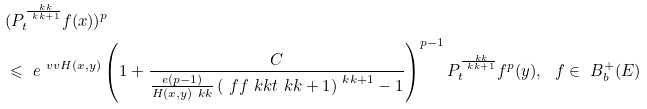<formula> <loc_0><loc_0><loc_500><loc_500>& ( P _ { t } ^ { \frac { \ k k } { \ k k + 1 } } f ( x ) ) ^ { p } \\ & \leqslant \ e ^ { \ v v H ( x , y ) } \left ( 1 + \frac { C } { \frac { e ( p - 1 ) } { H ( x , y ) \ k k } \left ( \ f f { \ k k t } { \ k k + 1 } \right ) ^ { \ k k + 1 } - 1 } \right ) ^ { p - 1 } P _ { t } ^ { \frac { \ k k } { \ k k + 1 } } f ^ { p } ( y ) , \ \ f \in \ B _ { b } ^ { + } ( E )</formula> 